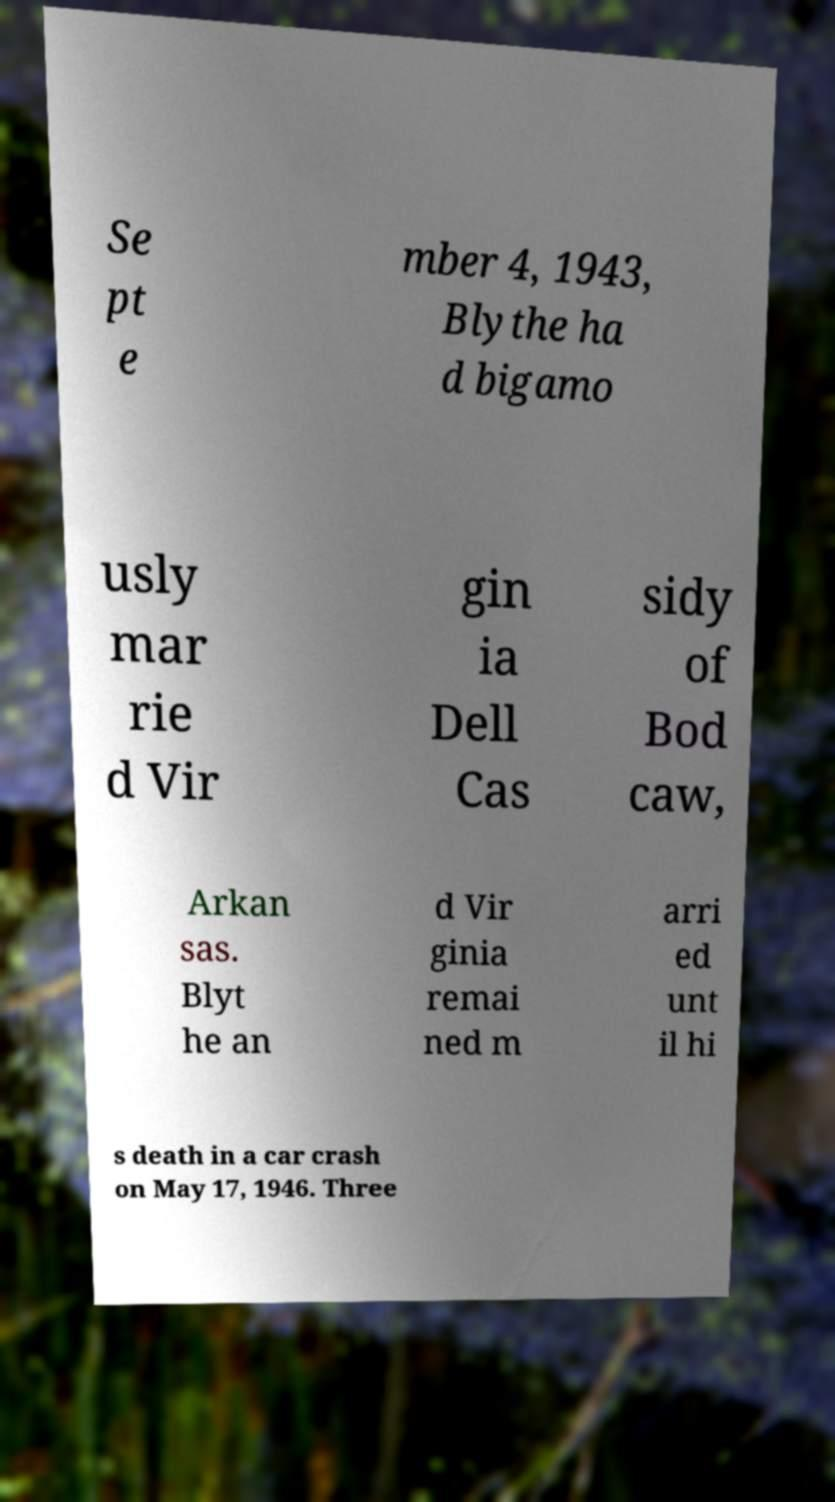For documentation purposes, I need the text within this image transcribed. Could you provide that? Se pt e mber 4, 1943, Blythe ha d bigamo usly mar rie d Vir gin ia Dell Cas sidy of Bod caw, Arkan sas. Blyt he an d Vir ginia remai ned m arri ed unt il hi s death in a car crash on May 17, 1946. Three 